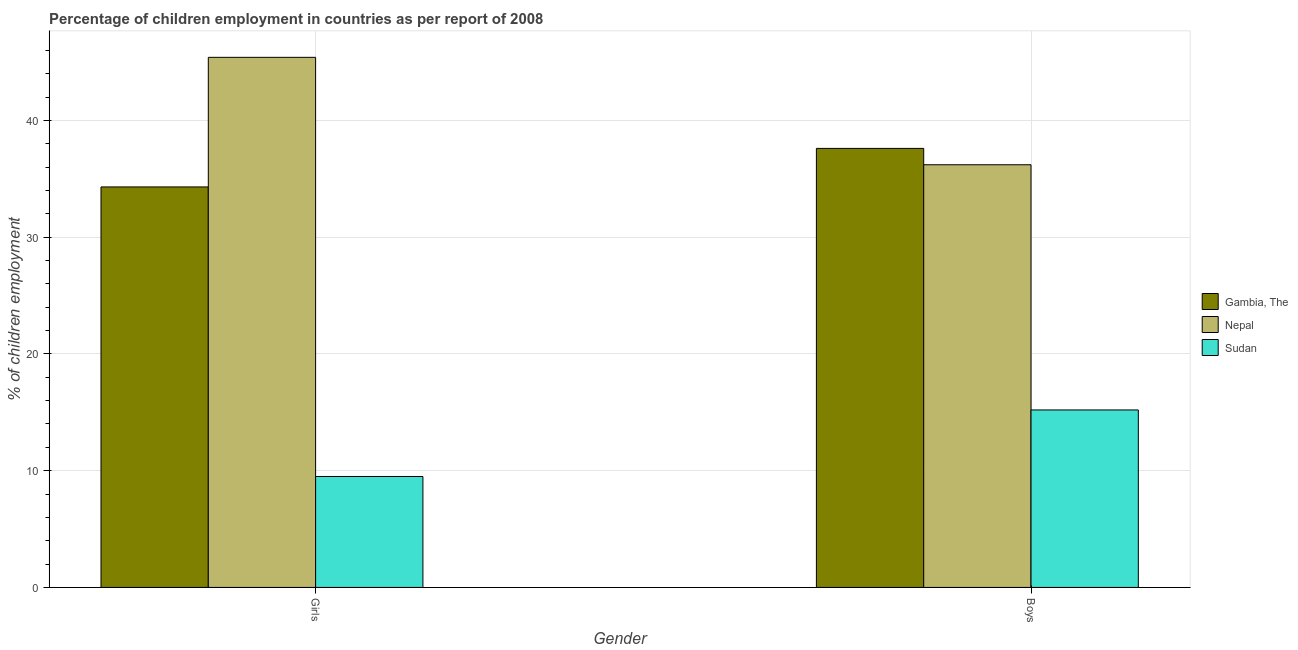How many different coloured bars are there?
Your response must be concise. 3. How many groups of bars are there?
Offer a terse response. 2. Are the number of bars per tick equal to the number of legend labels?
Provide a succinct answer. Yes. Are the number of bars on each tick of the X-axis equal?
Your answer should be compact. Yes. How many bars are there on the 2nd tick from the left?
Offer a very short reply. 3. What is the label of the 2nd group of bars from the left?
Ensure brevity in your answer.  Boys. What is the percentage of employed girls in Gambia, The?
Keep it short and to the point. 34.3. Across all countries, what is the maximum percentage of employed boys?
Your response must be concise. 37.6. Across all countries, what is the minimum percentage of employed boys?
Provide a short and direct response. 15.2. In which country was the percentage of employed girls maximum?
Your response must be concise. Nepal. In which country was the percentage of employed boys minimum?
Offer a very short reply. Sudan. What is the total percentage of employed boys in the graph?
Give a very brief answer. 89. What is the difference between the percentage of employed girls in Gambia, The and that in Sudan?
Make the answer very short. 24.8. What is the difference between the percentage of employed girls in Nepal and the percentage of employed boys in Gambia, The?
Provide a succinct answer. 7.8. What is the average percentage of employed boys per country?
Your answer should be very brief. 29.67. What is the difference between the percentage of employed girls and percentage of employed boys in Gambia, The?
Your response must be concise. -3.3. In how many countries, is the percentage of employed girls greater than 40 %?
Make the answer very short. 1. What is the ratio of the percentage of employed boys in Sudan to that in Nepal?
Your response must be concise. 0.42. Is the percentage of employed girls in Sudan less than that in Gambia, The?
Your answer should be compact. Yes. What does the 3rd bar from the left in Girls represents?
Provide a succinct answer. Sudan. What does the 1st bar from the right in Girls represents?
Make the answer very short. Sudan. How many countries are there in the graph?
Ensure brevity in your answer.  3. What is the difference between two consecutive major ticks on the Y-axis?
Offer a terse response. 10. Are the values on the major ticks of Y-axis written in scientific E-notation?
Ensure brevity in your answer.  No. Does the graph contain grids?
Make the answer very short. Yes. Where does the legend appear in the graph?
Provide a succinct answer. Center right. What is the title of the graph?
Ensure brevity in your answer.  Percentage of children employment in countries as per report of 2008. Does "Paraguay" appear as one of the legend labels in the graph?
Give a very brief answer. No. What is the label or title of the X-axis?
Your answer should be compact. Gender. What is the label or title of the Y-axis?
Provide a short and direct response. % of children employment. What is the % of children employment of Gambia, The in Girls?
Your response must be concise. 34.3. What is the % of children employment of Nepal in Girls?
Ensure brevity in your answer.  45.4. What is the % of children employment of Sudan in Girls?
Provide a short and direct response. 9.5. What is the % of children employment of Gambia, The in Boys?
Make the answer very short. 37.6. What is the % of children employment of Nepal in Boys?
Offer a very short reply. 36.2. Across all Gender, what is the maximum % of children employment of Gambia, The?
Provide a short and direct response. 37.6. Across all Gender, what is the maximum % of children employment of Nepal?
Ensure brevity in your answer.  45.4. Across all Gender, what is the maximum % of children employment of Sudan?
Offer a very short reply. 15.2. Across all Gender, what is the minimum % of children employment in Gambia, The?
Provide a succinct answer. 34.3. Across all Gender, what is the minimum % of children employment of Nepal?
Offer a very short reply. 36.2. Across all Gender, what is the minimum % of children employment of Sudan?
Make the answer very short. 9.5. What is the total % of children employment in Gambia, The in the graph?
Make the answer very short. 71.9. What is the total % of children employment in Nepal in the graph?
Your answer should be compact. 81.6. What is the total % of children employment of Sudan in the graph?
Ensure brevity in your answer.  24.7. What is the difference between the % of children employment in Gambia, The in Girls and that in Boys?
Your response must be concise. -3.3. What is the difference between the % of children employment in Sudan in Girls and that in Boys?
Keep it short and to the point. -5.7. What is the difference between the % of children employment of Gambia, The in Girls and the % of children employment of Sudan in Boys?
Provide a succinct answer. 19.1. What is the difference between the % of children employment in Nepal in Girls and the % of children employment in Sudan in Boys?
Offer a very short reply. 30.2. What is the average % of children employment of Gambia, The per Gender?
Offer a very short reply. 35.95. What is the average % of children employment of Nepal per Gender?
Make the answer very short. 40.8. What is the average % of children employment of Sudan per Gender?
Your response must be concise. 12.35. What is the difference between the % of children employment of Gambia, The and % of children employment of Nepal in Girls?
Make the answer very short. -11.1. What is the difference between the % of children employment of Gambia, The and % of children employment of Sudan in Girls?
Your answer should be compact. 24.8. What is the difference between the % of children employment in Nepal and % of children employment in Sudan in Girls?
Your answer should be very brief. 35.9. What is the difference between the % of children employment of Gambia, The and % of children employment of Sudan in Boys?
Ensure brevity in your answer.  22.4. What is the ratio of the % of children employment in Gambia, The in Girls to that in Boys?
Give a very brief answer. 0.91. What is the ratio of the % of children employment in Nepal in Girls to that in Boys?
Your answer should be compact. 1.25. What is the difference between the highest and the second highest % of children employment of Gambia, The?
Your response must be concise. 3.3. What is the difference between the highest and the second highest % of children employment of Nepal?
Make the answer very short. 9.2. What is the difference between the highest and the second highest % of children employment in Sudan?
Your answer should be compact. 5.7. What is the difference between the highest and the lowest % of children employment in Gambia, The?
Offer a terse response. 3.3. What is the difference between the highest and the lowest % of children employment of Nepal?
Your answer should be very brief. 9.2. What is the difference between the highest and the lowest % of children employment in Sudan?
Your answer should be compact. 5.7. 